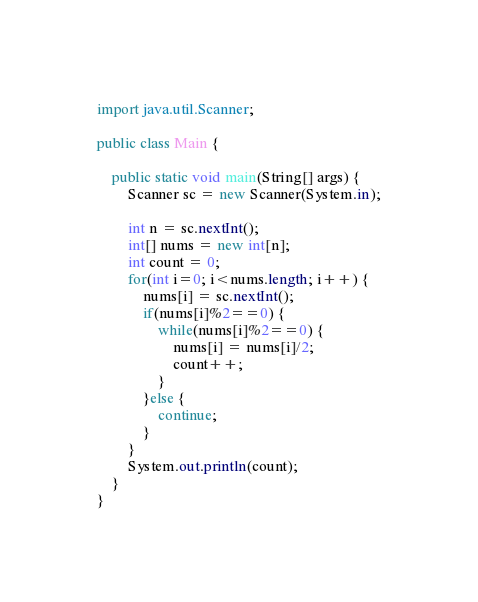<code> <loc_0><loc_0><loc_500><loc_500><_Java_>import java.util.Scanner;

public class Main {

	public static void main(String[] args) {
		Scanner sc = new Scanner(System.in);
		
		int n = sc.nextInt();
		int[] nums = new int[n];
		int count = 0;
		for(int i=0; i<nums.length; i++) {
			nums[i] = sc.nextInt();
			if(nums[i]%2==0) {
				while(nums[i]%2==0) {
					nums[i] = nums[i]/2;
					count++;
				}
			}else {
				continue;
			}
		}
		System.out.println(count);
	}
}
</code> 